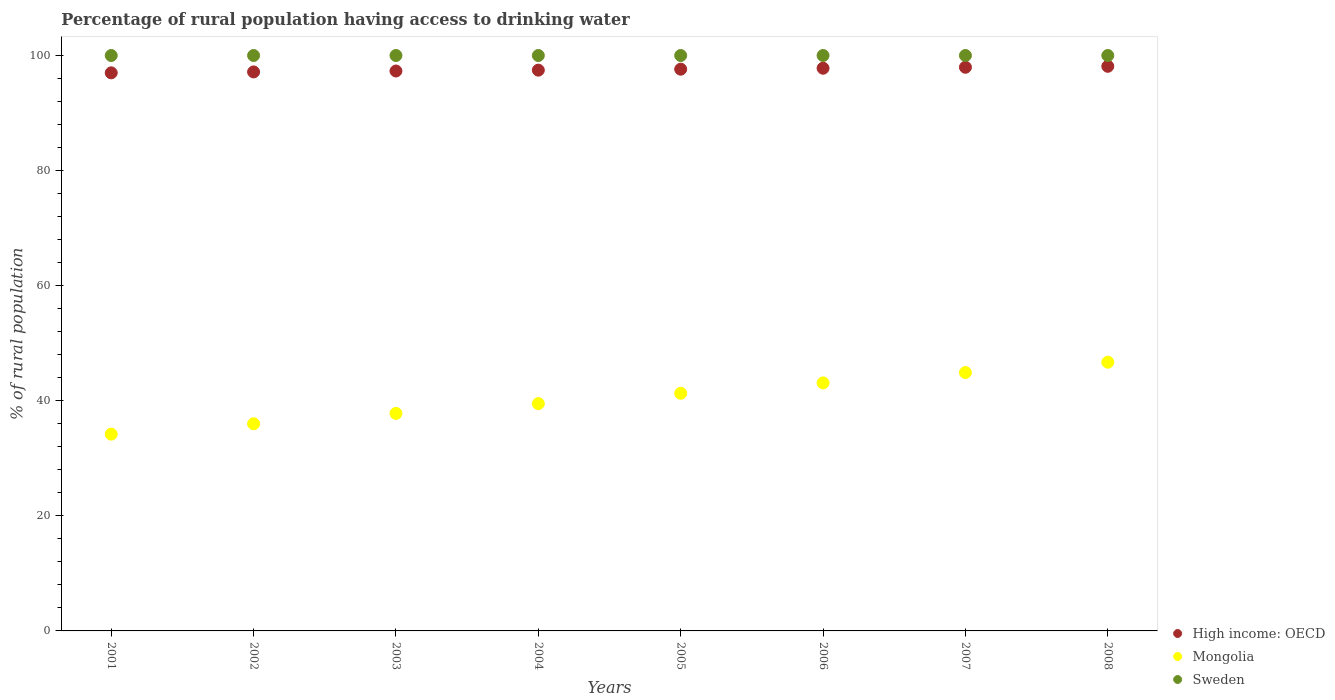Is the number of dotlines equal to the number of legend labels?
Provide a succinct answer. Yes. What is the percentage of rural population having access to drinking water in Sweden in 2004?
Provide a succinct answer. 100. Across all years, what is the maximum percentage of rural population having access to drinking water in High income: OECD?
Provide a short and direct response. 98.12. Across all years, what is the minimum percentage of rural population having access to drinking water in High income: OECD?
Provide a short and direct response. 96.99. What is the total percentage of rural population having access to drinking water in Sweden in the graph?
Ensure brevity in your answer.  800. What is the difference between the percentage of rural population having access to drinking water in High income: OECD in 2001 and that in 2007?
Your response must be concise. -0.97. What is the difference between the percentage of rural population having access to drinking water in Sweden in 2006 and the percentage of rural population having access to drinking water in Mongolia in 2001?
Provide a succinct answer. 65.8. What is the average percentage of rural population having access to drinking water in High income: OECD per year?
Make the answer very short. 97.55. In the year 2003, what is the difference between the percentage of rural population having access to drinking water in Mongolia and percentage of rural population having access to drinking water in High income: OECD?
Give a very brief answer. -59.51. In how many years, is the percentage of rural population having access to drinking water in Sweden greater than 68 %?
Offer a terse response. 8. What is the ratio of the percentage of rural population having access to drinking water in High income: OECD in 2002 to that in 2006?
Offer a terse response. 0.99. Is the percentage of rural population having access to drinking water in Mongolia in 2003 less than that in 2008?
Your answer should be very brief. Yes. What is the difference between the highest and the second highest percentage of rural population having access to drinking water in Sweden?
Provide a succinct answer. 0. What is the difference between the highest and the lowest percentage of rural population having access to drinking water in Sweden?
Your response must be concise. 0. Does the percentage of rural population having access to drinking water in Mongolia monotonically increase over the years?
Make the answer very short. Yes. Is the percentage of rural population having access to drinking water in High income: OECD strictly greater than the percentage of rural population having access to drinking water in Sweden over the years?
Keep it short and to the point. No. Is the percentage of rural population having access to drinking water in Sweden strictly less than the percentage of rural population having access to drinking water in Mongolia over the years?
Your response must be concise. No. How many years are there in the graph?
Offer a terse response. 8. Are the values on the major ticks of Y-axis written in scientific E-notation?
Provide a short and direct response. No. Does the graph contain any zero values?
Your answer should be very brief. No. Where does the legend appear in the graph?
Your answer should be compact. Bottom right. How many legend labels are there?
Offer a very short reply. 3. What is the title of the graph?
Ensure brevity in your answer.  Percentage of rural population having access to drinking water. Does "Argentina" appear as one of the legend labels in the graph?
Your answer should be compact. No. What is the label or title of the X-axis?
Make the answer very short. Years. What is the label or title of the Y-axis?
Offer a terse response. % of rural population. What is the % of rural population in High income: OECD in 2001?
Your answer should be compact. 96.99. What is the % of rural population of Mongolia in 2001?
Your response must be concise. 34.2. What is the % of rural population in High income: OECD in 2002?
Offer a terse response. 97.15. What is the % of rural population of Mongolia in 2002?
Your answer should be very brief. 36. What is the % of rural population in Sweden in 2002?
Provide a short and direct response. 100. What is the % of rural population in High income: OECD in 2003?
Keep it short and to the point. 97.31. What is the % of rural population of Mongolia in 2003?
Give a very brief answer. 37.8. What is the % of rural population of High income: OECD in 2004?
Your answer should be very brief. 97.45. What is the % of rural population in Mongolia in 2004?
Your answer should be very brief. 39.5. What is the % of rural population in Sweden in 2004?
Keep it short and to the point. 100. What is the % of rural population in High income: OECD in 2005?
Give a very brief answer. 97.62. What is the % of rural population in Mongolia in 2005?
Give a very brief answer. 41.3. What is the % of rural population of High income: OECD in 2006?
Provide a short and direct response. 97.79. What is the % of rural population of Mongolia in 2006?
Offer a terse response. 43.1. What is the % of rural population of High income: OECD in 2007?
Offer a terse response. 97.96. What is the % of rural population in Mongolia in 2007?
Keep it short and to the point. 44.9. What is the % of rural population in Sweden in 2007?
Keep it short and to the point. 100. What is the % of rural population in High income: OECD in 2008?
Your answer should be compact. 98.12. What is the % of rural population in Mongolia in 2008?
Ensure brevity in your answer.  46.7. Across all years, what is the maximum % of rural population in High income: OECD?
Provide a short and direct response. 98.12. Across all years, what is the maximum % of rural population of Mongolia?
Keep it short and to the point. 46.7. Across all years, what is the maximum % of rural population in Sweden?
Offer a very short reply. 100. Across all years, what is the minimum % of rural population in High income: OECD?
Provide a short and direct response. 96.99. Across all years, what is the minimum % of rural population in Mongolia?
Provide a succinct answer. 34.2. What is the total % of rural population of High income: OECD in the graph?
Provide a short and direct response. 780.38. What is the total % of rural population of Mongolia in the graph?
Your answer should be very brief. 323.5. What is the total % of rural population in Sweden in the graph?
Your response must be concise. 800. What is the difference between the % of rural population in High income: OECD in 2001 and that in 2002?
Your answer should be compact. -0.16. What is the difference between the % of rural population of High income: OECD in 2001 and that in 2003?
Provide a succinct answer. -0.32. What is the difference between the % of rural population of Sweden in 2001 and that in 2003?
Your answer should be compact. 0. What is the difference between the % of rural population in High income: OECD in 2001 and that in 2004?
Provide a succinct answer. -0.47. What is the difference between the % of rural population of Sweden in 2001 and that in 2004?
Keep it short and to the point. 0. What is the difference between the % of rural population in High income: OECD in 2001 and that in 2005?
Provide a succinct answer. -0.64. What is the difference between the % of rural population in Mongolia in 2001 and that in 2005?
Ensure brevity in your answer.  -7.1. What is the difference between the % of rural population in Sweden in 2001 and that in 2005?
Offer a terse response. 0. What is the difference between the % of rural population of High income: OECD in 2001 and that in 2006?
Ensure brevity in your answer.  -0.8. What is the difference between the % of rural population in High income: OECD in 2001 and that in 2007?
Offer a very short reply. -0.97. What is the difference between the % of rural population in Mongolia in 2001 and that in 2007?
Ensure brevity in your answer.  -10.7. What is the difference between the % of rural population of Sweden in 2001 and that in 2007?
Your answer should be very brief. 0. What is the difference between the % of rural population of High income: OECD in 2001 and that in 2008?
Your answer should be compact. -1.14. What is the difference between the % of rural population of Mongolia in 2001 and that in 2008?
Your answer should be very brief. -12.5. What is the difference between the % of rural population in Sweden in 2001 and that in 2008?
Keep it short and to the point. 0. What is the difference between the % of rural population of High income: OECD in 2002 and that in 2003?
Give a very brief answer. -0.16. What is the difference between the % of rural population of Mongolia in 2002 and that in 2003?
Your answer should be very brief. -1.8. What is the difference between the % of rural population of Sweden in 2002 and that in 2003?
Keep it short and to the point. 0. What is the difference between the % of rural population of High income: OECD in 2002 and that in 2004?
Provide a succinct answer. -0.31. What is the difference between the % of rural population of Mongolia in 2002 and that in 2004?
Ensure brevity in your answer.  -3.5. What is the difference between the % of rural population of High income: OECD in 2002 and that in 2005?
Provide a short and direct response. -0.48. What is the difference between the % of rural population in High income: OECD in 2002 and that in 2006?
Keep it short and to the point. -0.64. What is the difference between the % of rural population of Sweden in 2002 and that in 2006?
Ensure brevity in your answer.  0. What is the difference between the % of rural population of High income: OECD in 2002 and that in 2007?
Provide a short and direct response. -0.81. What is the difference between the % of rural population in High income: OECD in 2002 and that in 2008?
Your answer should be very brief. -0.98. What is the difference between the % of rural population in High income: OECD in 2003 and that in 2004?
Give a very brief answer. -0.15. What is the difference between the % of rural population in Mongolia in 2003 and that in 2004?
Make the answer very short. -1.7. What is the difference between the % of rural population in High income: OECD in 2003 and that in 2005?
Provide a short and direct response. -0.32. What is the difference between the % of rural population in Sweden in 2003 and that in 2005?
Your answer should be very brief. 0. What is the difference between the % of rural population in High income: OECD in 2003 and that in 2006?
Provide a succinct answer. -0.48. What is the difference between the % of rural population of Sweden in 2003 and that in 2006?
Offer a terse response. 0. What is the difference between the % of rural population in High income: OECD in 2003 and that in 2007?
Keep it short and to the point. -0.65. What is the difference between the % of rural population in Mongolia in 2003 and that in 2007?
Your answer should be compact. -7.1. What is the difference between the % of rural population in High income: OECD in 2003 and that in 2008?
Ensure brevity in your answer.  -0.82. What is the difference between the % of rural population of Mongolia in 2003 and that in 2008?
Your answer should be compact. -8.9. What is the difference between the % of rural population of Sweden in 2003 and that in 2008?
Keep it short and to the point. 0. What is the difference between the % of rural population in High income: OECD in 2004 and that in 2005?
Your answer should be very brief. -0.17. What is the difference between the % of rural population of High income: OECD in 2004 and that in 2006?
Provide a succinct answer. -0.33. What is the difference between the % of rural population in Sweden in 2004 and that in 2006?
Give a very brief answer. 0. What is the difference between the % of rural population of High income: OECD in 2004 and that in 2007?
Make the answer very short. -0.5. What is the difference between the % of rural population of Mongolia in 2004 and that in 2007?
Provide a succinct answer. -5.4. What is the difference between the % of rural population of Sweden in 2004 and that in 2007?
Make the answer very short. 0. What is the difference between the % of rural population in High income: OECD in 2004 and that in 2008?
Your answer should be very brief. -0.67. What is the difference between the % of rural population in High income: OECD in 2005 and that in 2006?
Your response must be concise. -0.17. What is the difference between the % of rural population of Mongolia in 2005 and that in 2006?
Offer a very short reply. -1.8. What is the difference between the % of rural population in Sweden in 2005 and that in 2006?
Keep it short and to the point. 0. What is the difference between the % of rural population of High income: OECD in 2005 and that in 2007?
Your answer should be compact. -0.33. What is the difference between the % of rural population of Mongolia in 2005 and that in 2007?
Your response must be concise. -3.6. What is the difference between the % of rural population in Sweden in 2005 and that in 2007?
Keep it short and to the point. 0. What is the difference between the % of rural population of High income: OECD in 2005 and that in 2008?
Offer a terse response. -0.5. What is the difference between the % of rural population of Mongolia in 2005 and that in 2008?
Offer a very short reply. -5.4. What is the difference between the % of rural population in Mongolia in 2006 and that in 2007?
Make the answer very short. -1.8. What is the difference between the % of rural population of High income: OECD in 2006 and that in 2008?
Make the answer very short. -0.33. What is the difference between the % of rural population in Mongolia in 2006 and that in 2008?
Provide a succinct answer. -3.6. What is the difference between the % of rural population of Sweden in 2006 and that in 2008?
Ensure brevity in your answer.  0. What is the difference between the % of rural population in High income: OECD in 2007 and that in 2008?
Keep it short and to the point. -0.17. What is the difference between the % of rural population in Mongolia in 2007 and that in 2008?
Offer a terse response. -1.8. What is the difference between the % of rural population in High income: OECD in 2001 and the % of rural population in Mongolia in 2002?
Your response must be concise. 60.99. What is the difference between the % of rural population in High income: OECD in 2001 and the % of rural population in Sweden in 2002?
Keep it short and to the point. -3.01. What is the difference between the % of rural population of Mongolia in 2001 and the % of rural population of Sweden in 2002?
Ensure brevity in your answer.  -65.8. What is the difference between the % of rural population in High income: OECD in 2001 and the % of rural population in Mongolia in 2003?
Provide a short and direct response. 59.19. What is the difference between the % of rural population of High income: OECD in 2001 and the % of rural population of Sweden in 2003?
Keep it short and to the point. -3.01. What is the difference between the % of rural population of Mongolia in 2001 and the % of rural population of Sweden in 2003?
Make the answer very short. -65.8. What is the difference between the % of rural population of High income: OECD in 2001 and the % of rural population of Mongolia in 2004?
Your response must be concise. 57.49. What is the difference between the % of rural population in High income: OECD in 2001 and the % of rural population in Sweden in 2004?
Provide a succinct answer. -3.01. What is the difference between the % of rural population in Mongolia in 2001 and the % of rural population in Sweden in 2004?
Make the answer very short. -65.8. What is the difference between the % of rural population in High income: OECD in 2001 and the % of rural population in Mongolia in 2005?
Your response must be concise. 55.69. What is the difference between the % of rural population of High income: OECD in 2001 and the % of rural population of Sweden in 2005?
Keep it short and to the point. -3.01. What is the difference between the % of rural population of Mongolia in 2001 and the % of rural population of Sweden in 2005?
Provide a succinct answer. -65.8. What is the difference between the % of rural population of High income: OECD in 2001 and the % of rural population of Mongolia in 2006?
Give a very brief answer. 53.89. What is the difference between the % of rural population in High income: OECD in 2001 and the % of rural population in Sweden in 2006?
Provide a succinct answer. -3.01. What is the difference between the % of rural population of Mongolia in 2001 and the % of rural population of Sweden in 2006?
Offer a terse response. -65.8. What is the difference between the % of rural population in High income: OECD in 2001 and the % of rural population in Mongolia in 2007?
Keep it short and to the point. 52.09. What is the difference between the % of rural population of High income: OECD in 2001 and the % of rural population of Sweden in 2007?
Offer a very short reply. -3.01. What is the difference between the % of rural population of Mongolia in 2001 and the % of rural population of Sweden in 2007?
Make the answer very short. -65.8. What is the difference between the % of rural population of High income: OECD in 2001 and the % of rural population of Mongolia in 2008?
Offer a terse response. 50.29. What is the difference between the % of rural population of High income: OECD in 2001 and the % of rural population of Sweden in 2008?
Provide a succinct answer. -3.01. What is the difference between the % of rural population of Mongolia in 2001 and the % of rural population of Sweden in 2008?
Offer a terse response. -65.8. What is the difference between the % of rural population of High income: OECD in 2002 and the % of rural population of Mongolia in 2003?
Make the answer very short. 59.35. What is the difference between the % of rural population in High income: OECD in 2002 and the % of rural population in Sweden in 2003?
Your response must be concise. -2.85. What is the difference between the % of rural population in Mongolia in 2002 and the % of rural population in Sweden in 2003?
Provide a short and direct response. -64. What is the difference between the % of rural population in High income: OECD in 2002 and the % of rural population in Mongolia in 2004?
Ensure brevity in your answer.  57.65. What is the difference between the % of rural population of High income: OECD in 2002 and the % of rural population of Sweden in 2004?
Your answer should be compact. -2.85. What is the difference between the % of rural population in Mongolia in 2002 and the % of rural population in Sweden in 2004?
Your response must be concise. -64. What is the difference between the % of rural population in High income: OECD in 2002 and the % of rural population in Mongolia in 2005?
Make the answer very short. 55.85. What is the difference between the % of rural population of High income: OECD in 2002 and the % of rural population of Sweden in 2005?
Offer a terse response. -2.85. What is the difference between the % of rural population in Mongolia in 2002 and the % of rural population in Sweden in 2005?
Your answer should be very brief. -64. What is the difference between the % of rural population of High income: OECD in 2002 and the % of rural population of Mongolia in 2006?
Your response must be concise. 54.05. What is the difference between the % of rural population in High income: OECD in 2002 and the % of rural population in Sweden in 2006?
Provide a succinct answer. -2.85. What is the difference between the % of rural population of Mongolia in 2002 and the % of rural population of Sweden in 2006?
Offer a terse response. -64. What is the difference between the % of rural population of High income: OECD in 2002 and the % of rural population of Mongolia in 2007?
Make the answer very short. 52.25. What is the difference between the % of rural population of High income: OECD in 2002 and the % of rural population of Sweden in 2007?
Give a very brief answer. -2.85. What is the difference between the % of rural population of Mongolia in 2002 and the % of rural population of Sweden in 2007?
Provide a succinct answer. -64. What is the difference between the % of rural population of High income: OECD in 2002 and the % of rural population of Mongolia in 2008?
Give a very brief answer. 50.45. What is the difference between the % of rural population in High income: OECD in 2002 and the % of rural population in Sweden in 2008?
Provide a short and direct response. -2.85. What is the difference between the % of rural population in Mongolia in 2002 and the % of rural population in Sweden in 2008?
Your answer should be compact. -64. What is the difference between the % of rural population of High income: OECD in 2003 and the % of rural population of Mongolia in 2004?
Your answer should be very brief. 57.81. What is the difference between the % of rural population of High income: OECD in 2003 and the % of rural population of Sweden in 2004?
Keep it short and to the point. -2.69. What is the difference between the % of rural population of Mongolia in 2003 and the % of rural population of Sweden in 2004?
Your answer should be very brief. -62.2. What is the difference between the % of rural population of High income: OECD in 2003 and the % of rural population of Mongolia in 2005?
Your answer should be very brief. 56.01. What is the difference between the % of rural population in High income: OECD in 2003 and the % of rural population in Sweden in 2005?
Your response must be concise. -2.69. What is the difference between the % of rural population of Mongolia in 2003 and the % of rural population of Sweden in 2005?
Give a very brief answer. -62.2. What is the difference between the % of rural population of High income: OECD in 2003 and the % of rural population of Mongolia in 2006?
Provide a short and direct response. 54.21. What is the difference between the % of rural population in High income: OECD in 2003 and the % of rural population in Sweden in 2006?
Ensure brevity in your answer.  -2.69. What is the difference between the % of rural population in Mongolia in 2003 and the % of rural population in Sweden in 2006?
Ensure brevity in your answer.  -62.2. What is the difference between the % of rural population of High income: OECD in 2003 and the % of rural population of Mongolia in 2007?
Provide a short and direct response. 52.41. What is the difference between the % of rural population of High income: OECD in 2003 and the % of rural population of Sweden in 2007?
Give a very brief answer. -2.69. What is the difference between the % of rural population in Mongolia in 2003 and the % of rural population in Sweden in 2007?
Offer a very short reply. -62.2. What is the difference between the % of rural population of High income: OECD in 2003 and the % of rural population of Mongolia in 2008?
Ensure brevity in your answer.  50.61. What is the difference between the % of rural population in High income: OECD in 2003 and the % of rural population in Sweden in 2008?
Make the answer very short. -2.69. What is the difference between the % of rural population of Mongolia in 2003 and the % of rural population of Sweden in 2008?
Keep it short and to the point. -62.2. What is the difference between the % of rural population of High income: OECD in 2004 and the % of rural population of Mongolia in 2005?
Make the answer very short. 56.15. What is the difference between the % of rural population in High income: OECD in 2004 and the % of rural population in Sweden in 2005?
Your answer should be compact. -2.55. What is the difference between the % of rural population in Mongolia in 2004 and the % of rural population in Sweden in 2005?
Offer a very short reply. -60.5. What is the difference between the % of rural population in High income: OECD in 2004 and the % of rural population in Mongolia in 2006?
Ensure brevity in your answer.  54.35. What is the difference between the % of rural population of High income: OECD in 2004 and the % of rural population of Sweden in 2006?
Keep it short and to the point. -2.55. What is the difference between the % of rural population of Mongolia in 2004 and the % of rural population of Sweden in 2006?
Your response must be concise. -60.5. What is the difference between the % of rural population in High income: OECD in 2004 and the % of rural population in Mongolia in 2007?
Give a very brief answer. 52.55. What is the difference between the % of rural population of High income: OECD in 2004 and the % of rural population of Sweden in 2007?
Your response must be concise. -2.55. What is the difference between the % of rural population of Mongolia in 2004 and the % of rural population of Sweden in 2007?
Provide a short and direct response. -60.5. What is the difference between the % of rural population in High income: OECD in 2004 and the % of rural population in Mongolia in 2008?
Offer a terse response. 50.75. What is the difference between the % of rural population of High income: OECD in 2004 and the % of rural population of Sweden in 2008?
Your answer should be very brief. -2.55. What is the difference between the % of rural population in Mongolia in 2004 and the % of rural population in Sweden in 2008?
Provide a succinct answer. -60.5. What is the difference between the % of rural population in High income: OECD in 2005 and the % of rural population in Mongolia in 2006?
Your response must be concise. 54.52. What is the difference between the % of rural population of High income: OECD in 2005 and the % of rural population of Sweden in 2006?
Your answer should be compact. -2.38. What is the difference between the % of rural population of Mongolia in 2005 and the % of rural population of Sweden in 2006?
Keep it short and to the point. -58.7. What is the difference between the % of rural population of High income: OECD in 2005 and the % of rural population of Mongolia in 2007?
Provide a short and direct response. 52.72. What is the difference between the % of rural population of High income: OECD in 2005 and the % of rural population of Sweden in 2007?
Make the answer very short. -2.38. What is the difference between the % of rural population of Mongolia in 2005 and the % of rural population of Sweden in 2007?
Make the answer very short. -58.7. What is the difference between the % of rural population of High income: OECD in 2005 and the % of rural population of Mongolia in 2008?
Offer a terse response. 50.92. What is the difference between the % of rural population of High income: OECD in 2005 and the % of rural population of Sweden in 2008?
Your answer should be very brief. -2.38. What is the difference between the % of rural population of Mongolia in 2005 and the % of rural population of Sweden in 2008?
Provide a succinct answer. -58.7. What is the difference between the % of rural population in High income: OECD in 2006 and the % of rural population in Mongolia in 2007?
Give a very brief answer. 52.89. What is the difference between the % of rural population in High income: OECD in 2006 and the % of rural population in Sweden in 2007?
Provide a short and direct response. -2.21. What is the difference between the % of rural population in Mongolia in 2006 and the % of rural population in Sweden in 2007?
Offer a terse response. -56.9. What is the difference between the % of rural population of High income: OECD in 2006 and the % of rural population of Mongolia in 2008?
Ensure brevity in your answer.  51.09. What is the difference between the % of rural population in High income: OECD in 2006 and the % of rural population in Sweden in 2008?
Provide a succinct answer. -2.21. What is the difference between the % of rural population of Mongolia in 2006 and the % of rural population of Sweden in 2008?
Your answer should be very brief. -56.9. What is the difference between the % of rural population of High income: OECD in 2007 and the % of rural population of Mongolia in 2008?
Your answer should be very brief. 51.26. What is the difference between the % of rural population in High income: OECD in 2007 and the % of rural population in Sweden in 2008?
Ensure brevity in your answer.  -2.04. What is the difference between the % of rural population of Mongolia in 2007 and the % of rural population of Sweden in 2008?
Your answer should be very brief. -55.1. What is the average % of rural population in High income: OECD per year?
Provide a succinct answer. 97.55. What is the average % of rural population of Mongolia per year?
Provide a short and direct response. 40.44. In the year 2001, what is the difference between the % of rural population of High income: OECD and % of rural population of Mongolia?
Make the answer very short. 62.79. In the year 2001, what is the difference between the % of rural population of High income: OECD and % of rural population of Sweden?
Your answer should be very brief. -3.01. In the year 2001, what is the difference between the % of rural population of Mongolia and % of rural population of Sweden?
Ensure brevity in your answer.  -65.8. In the year 2002, what is the difference between the % of rural population in High income: OECD and % of rural population in Mongolia?
Keep it short and to the point. 61.15. In the year 2002, what is the difference between the % of rural population of High income: OECD and % of rural population of Sweden?
Provide a short and direct response. -2.85. In the year 2002, what is the difference between the % of rural population of Mongolia and % of rural population of Sweden?
Your response must be concise. -64. In the year 2003, what is the difference between the % of rural population of High income: OECD and % of rural population of Mongolia?
Give a very brief answer. 59.51. In the year 2003, what is the difference between the % of rural population in High income: OECD and % of rural population in Sweden?
Provide a succinct answer. -2.69. In the year 2003, what is the difference between the % of rural population in Mongolia and % of rural population in Sweden?
Provide a short and direct response. -62.2. In the year 2004, what is the difference between the % of rural population of High income: OECD and % of rural population of Mongolia?
Your answer should be compact. 57.95. In the year 2004, what is the difference between the % of rural population in High income: OECD and % of rural population in Sweden?
Offer a very short reply. -2.55. In the year 2004, what is the difference between the % of rural population in Mongolia and % of rural population in Sweden?
Provide a short and direct response. -60.5. In the year 2005, what is the difference between the % of rural population of High income: OECD and % of rural population of Mongolia?
Ensure brevity in your answer.  56.32. In the year 2005, what is the difference between the % of rural population of High income: OECD and % of rural population of Sweden?
Give a very brief answer. -2.38. In the year 2005, what is the difference between the % of rural population of Mongolia and % of rural population of Sweden?
Your response must be concise. -58.7. In the year 2006, what is the difference between the % of rural population in High income: OECD and % of rural population in Mongolia?
Provide a succinct answer. 54.69. In the year 2006, what is the difference between the % of rural population of High income: OECD and % of rural population of Sweden?
Your answer should be compact. -2.21. In the year 2006, what is the difference between the % of rural population of Mongolia and % of rural population of Sweden?
Provide a short and direct response. -56.9. In the year 2007, what is the difference between the % of rural population of High income: OECD and % of rural population of Mongolia?
Provide a short and direct response. 53.06. In the year 2007, what is the difference between the % of rural population of High income: OECD and % of rural population of Sweden?
Offer a terse response. -2.04. In the year 2007, what is the difference between the % of rural population in Mongolia and % of rural population in Sweden?
Your answer should be compact. -55.1. In the year 2008, what is the difference between the % of rural population in High income: OECD and % of rural population in Mongolia?
Your answer should be very brief. 51.42. In the year 2008, what is the difference between the % of rural population of High income: OECD and % of rural population of Sweden?
Give a very brief answer. -1.88. In the year 2008, what is the difference between the % of rural population in Mongolia and % of rural population in Sweden?
Keep it short and to the point. -53.3. What is the ratio of the % of rural population in High income: OECD in 2001 to that in 2002?
Make the answer very short. 1. What is the ratio of the % of rural population in Mongolia in 2001 to that in 2002?
Your answer should be compact. 0.95. What is the ratio of the % of rural population in High income: OECD in 2001 to that in 2003?
Your answer should be very brief. 1. What is the ratio of the % of rural population in Mongolia in 2001 to that in 2003?
Keep it short and to the point. 0.9. What is the ratio of the % of rural population of Sweden in 2001 to that in 2003?
Offer a very short reply. 1. What is the ratio of the % of rural population in High income: OECD in 2001 to that in 2004?
Your response must be concise. 1. What is the ratio of the % of rural population of Mongolia in 2001 to that in 2004?
Provide a succinct answer. 0.87. What is the ratio of the % of rural population in Sweden in 2001 to that in 2004?
Give a very brief answer. 1. What is the ratio of the % of rural population in Mongolia in 2001 to that in 2005?
Your answer should be compact. 0.83. What is the ratio of the % of rural population in High income: OECD in 2001 to that in 2006?
Give a very brief answer. 0.99. What is the ratio of the % of rural population in Mongolia in 2001 to that in 2006?
Make the answer very short. 0.79. What is the ratio of the % of rural population of Mongolia in 2001 to that in 2007?
Your answer should be compact. 0.76. What is the ratio of the % of rural population of High income: OECD in 2001 to that in 2008?
Offer a terse response. 0.99. What is the ratio of the % of rural population in Mongolia in 2001 to that in 2008?
Provide a short and direct response. 0.73. What is the ratio of the % of rural population of Mongolia in 2002 to that in 2003?
Keep it short and to the point. 0.95. What is the ratio of the % of rural population in High income: OECD in 2002 to that in 2004?
Make the answer very short. 1. What is the ratio of the % of rural population in Mongolia in 2002 to that in 2004?
Ensure brevity in your answer.  0.91. What is the ratio of the % of rural population of Mongolia in 2002 to that in 2005?
Your response must be concise. 0.87. What is the ratio of the % of rural population in High income: OECD in 2002 to that in 2006?
Make the answer very short. 0.99. What is the ratio of the % of rural population in Mongolia in 2002 to that in 2006?
Keep it short and to the point. 0.84. What is the ratio of the % of rural population in Sweden in 2002 to that in 2006?
Give a very brief answer. 1. What is the ratio of the % of rural population of High income: OECD in 2002 to that in 2007?
Your response must be concise. 0.99. What is the ratio of the % of rural population of Mongolia in 2002 to that in 2007?
Keep it short and to the point. 0.8. What is the ratio of the % of rural population of Sweden in 2002 to that in 2007?
Your answer should be very brief. 1. What is the ratio of the % of rural population of Mongolia in 2002 to that in 2008?
Provide a short and direct response. 0.77. What is the ratio of the % of rural population in High income: OECD in 2003 to that in 2004?
Provide a succinct answer. 1. What is the ratio of the % of rural population in Sweden in 2003 to that in 2004?
Provide a succinct answer. 1. What is the ratio of the % of rural population of Mongolia in 2003 to that in 2005?
Your answer should be very brief. 0.92. What is the ratio of the % of rural population of Sweden in 2003 to that in 2005?
Offer a very short reply. 1. What is the ratio of the % of rural population of High income: OECD in 2003 to that in 2006?
Your answer should be compact. 1. What is the ratio of the % of rural population of Mongolia in 2003 to that in 2006?
Offer a terse response. 0.88. What is the ratio of the % of rural population of Mongolia in 2003 to that in 2007?
Offer a very short reply. 0.84. What is the ratio of the % of rural population in Sweden in 2003 to that in 2007?
Provide a succinct answer. 1. What is the ratio of the % of rural population of High income: OECD in 2003 to that in 2008?
Give a very brief answer. 0.99. What is the ratio of the % of rural population of Mongolia in 2003 to that in 2008?
Provide a short and direct response. 0.81. What is the ratio of the % of rural population in Sweden in 2003 to that in 2008?
Your answer should be very brief. 1. What is the ratio of the % of rural population in High income: OECD in 2004 to that in 2005?
Your response must be concise. 1. What is the ratio of the % of rural population of Mongolia in 2004 to that in 2005?
Your response must be concise. 0.96. What is the ratio of the % of rural population of Sweden in 2004 to that in 2005?
Offer a very short reply. 1. What is the ratio of the % of rural population in High income: OECD in 2004 to that in 2006?
Provide a succinct answer. 1. What is the ratio of the % of rural population in Mongolia in 2004 to that in 2006?
Your response must be concise. 0.92. What is the ratio of the % of rural population of Sweden in 2004 to that in 2006?
Provide a succinct answer. 1. What is the ratio of the % of rural population in Mongolia in 2004 to that in 2007?
Give a very brief answer. 0.88. What is the ratio of the % of rural population in High income: OECD in 2004 to that in 2008?
Offer a terse response. 0.99. What is the ratio of the % of rural population in Mongolia in 2004 to that in 2008?
Your answer should be very brief. 0.85. What is the ratio of the % of rural population in Sweden in 2004 to that in 2008?
Ensure brevity in your answer.  1. What is the ratio of the % of rural population of High income: OECD in 2005 to that in 2006?
Offer a terse response. 1. What is the ratio of the % of rural population of Mongolia in 2005 to that in 2006?
Give a very brief answer. 0.96. What is the ratio of the % of rural population of High income: OECD in 2005 to that in 2007?
Give a very brief answer. 1. What is the ratio of the % of rural population in Mongolia in 2005 to that in 2007?
Make the answer very short. 0.92. What is the ratio of the % of rural population of Sweden in 2005 to that in 2007?
Your answer should be very brief. 1. What is the ratio of the % of rural population in High income: OECD in 2005 to that in 2008?
Ensure brevity in your answer.  0.99. What is the ratio of the % of rural population of Mongolia in 2005 to that in 2008?
Keep it short and to the point. 0.88. What is the ratio of the % of rural population in Sweden in 2005 to that in 2008?
Offer a very short reply. 1. What is the ratio of the % of rural population of High income: OECD in 2006 to that in 2007?
Your answer should be very brief. 1. What is the ratio of the % of rural population of Mongolia in 2006 to that in 2007?
Make the answer very short. 0.96. What is the ratio of the % of rural population in Sweden in 2006 to that in 2007?
Offer a terse response. 1. What is the ratio of the % of rural population of High income: OECD in 2006 to that in 2008?
Your answer should be very brief. 1. What is the ratio of the % of rural population of Mongolia in 2006 to that in 2008?
Your response must be concise. 0.92. What is the ratio of the % of rural population in Sweden in 2006 to that in 2008?
Your answer should be very brief. 1. What is the ratio of the % of rural population in Mongolia in 2007 to that in 2008?
Your answer should be very brief. 0.96. What is the difference between the highest and the second highest % of rural population of High income: OECD?
Your answer should be very brief. 0.17. What is the difference between the highest and the second highest % of rural population of Mongolia?
Your answer should be very brief. 1.8. What is the difference between the highest and the lowest % of rural population of High income: OECD?
Your answer should be compact. 1.14. 